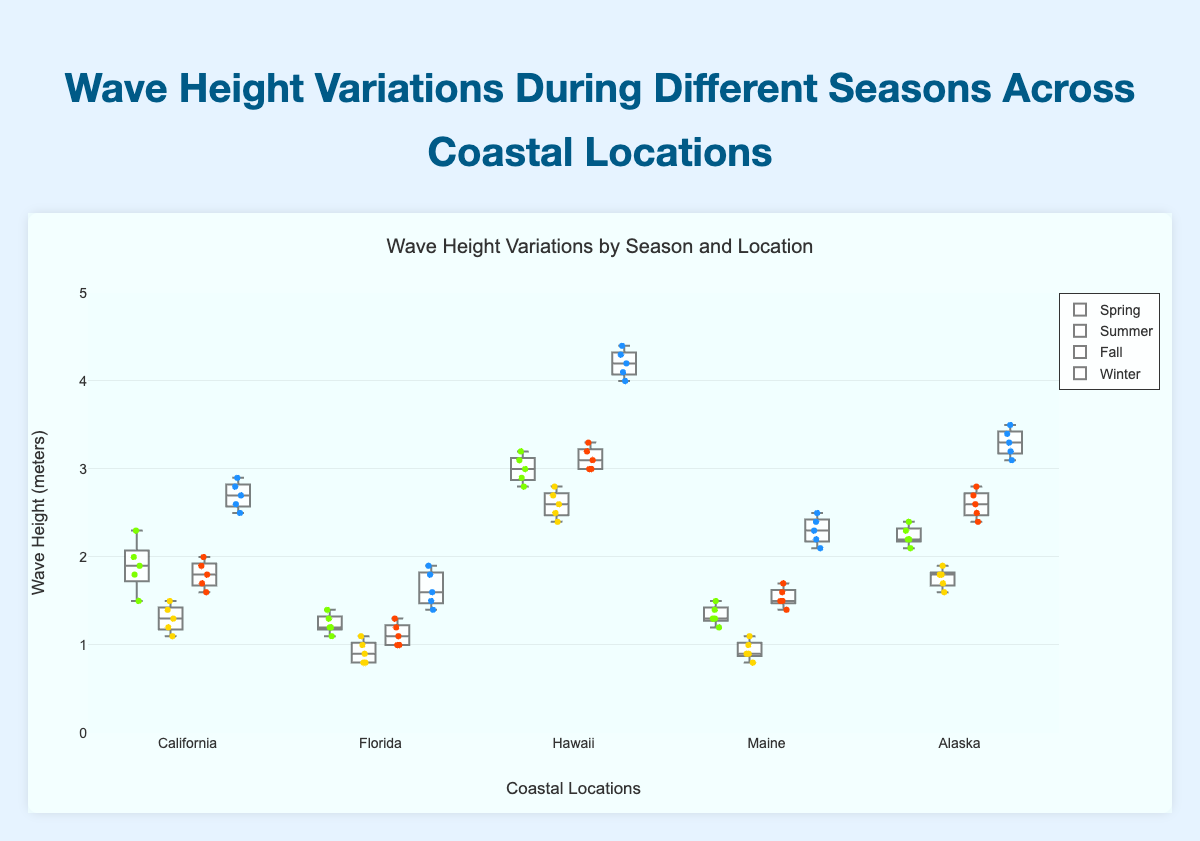What's the title of the figure? The title is commonly positioned at the top of the figure and summarizes the content. It helps viewers quickly grasp the main topic.
Answer: Wave Height Variations During Different Seasons Across Coastal Locations What is the y-axis representing? The y-axis label, "Wave Height (meters)," indicates that the vertical axis measures the wave heights in meters for different seasons and locations.
Answer: Wave Height (meters) Which coastal location has the highest wave height in Winter? By examining the box plot for Winter, we see that the tallest box belongs to Hawaii, indicating that this location has the highest wave heights in Winter.
Answer: Hawaii How does the wave height in California compare between Summer and Winter? By comparing the boxes for California in Summer and Winter, we notice that the median and overall wave heights are greater in Winter than in Summer.
Answer: Higher in Winter What season has the highest variation of wave heights for Alaska? Variation is indicated by the spread of the box plot. For Alaska, the Winter season box is the tallest, suggesting the highest variation in wave heights.
Answer: Winter Which season typically has the lowest wave heights across most locations? By comparing the positions of the boxes, Summer consistently shows lower wave heights across various locations, with the lowest positions overall.
Answer: Summer Is the median wave height in Alaska during Fall higher than in Spring? Check the line within the box plots for Alaska in Fall and Spring to see their median positions. The Fall median is above the Spring median.
Answer: Yes What is the range of wave heights in Florida during Winter? The range of a box plot is from the minimum to the maximum values. For Florida in Winter, the plots range from 1.4 to 1.9 meters.
Answer: 1.4 to 1.9 meters What coastal location shows the greatest median wave height overall? Compare the median lines across all boxes in all locations and seasons. Hawaii in Winter stands out with the highest median wave height.
Answer: Hawaii Is the wave height in Maine in Spring more variable than in Summer? By examining the box heights and their whiskers, the Spring season in Maine has a greater spread than Summer, indicating more variability.
Answer: Yes 